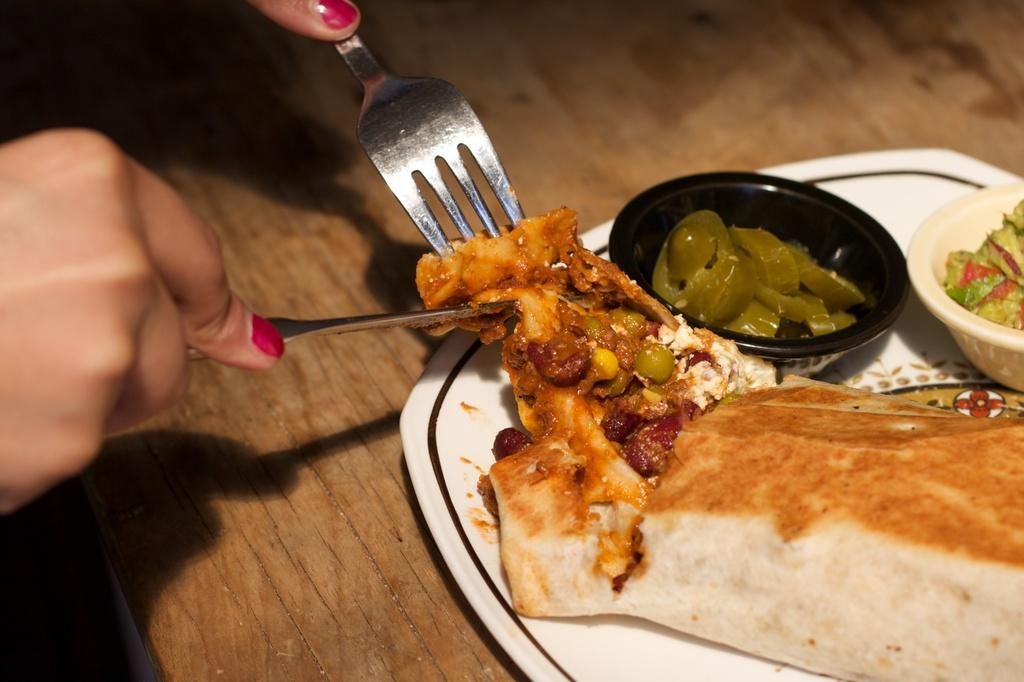What is on the plate that is visible in the image? There are food items on a plate in the image. Where is the plate located in the image? The plate is placed on a table in the image. What is the person in the image holding in their hands? The person is holding a fork and a knife in their hands. What type of bike can be seen in the image? There is no bike present in the image. What does the person in the image believe about the food on the plate? The image does not provide any information about the person's beliefs or opinions about the food on the plate. 